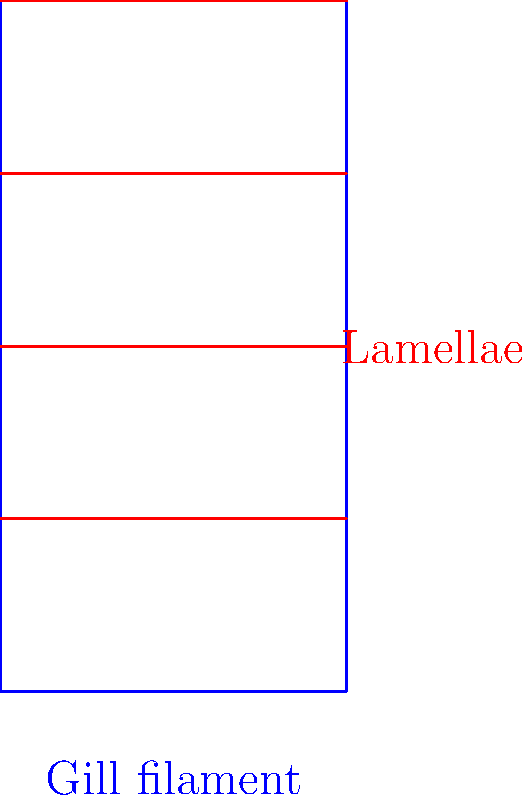In the cross-section of a fish gill shown above, which structural feature primarily contributes to maximizing the surface area for oxygen exchange, and how does this relate to the efficiency of respiration in aquatic environments? 1. Observe the structure: The diagram shows a cross-section of a fish gill, with a blue gill filament and red lamellae.

2. Identify key features: The lamellae are thin, plate-like structures extending from the gill filament.

3. Surface area principle: Increased surface area allows for more efficient gas exchange.

4. Role of lamellae: 
   a) They greatly increase the surface area of the gill without significantly increasing its volume.
   b) More surface area means more contact between water and blood vessels for oxygen exchange.

5. Efficiency in aquatic environments:
   a) Water has less available oxygen than air.
   b) Maximizing surface area is crucial for efficient oxygen uptake in water.

6. Quantitative perspective: The total surface area of gills can be up to 60 times greater than the external surface area of a fish's body due to the lamellae.

7. Countercurrent exchange: The lamellae also facilitate countercurrent flow, where water and blood flow in opposite directions, maximizing oxygen transfer efficiency.

Therefore, the lamellae are the primary structural feature contributing to maximizing surface area for oxygen exchange, significantly enhancing respiratory efficiency in aquatic environments.
Answer: Lamellae 